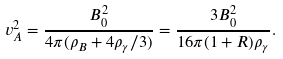<formula> <loc_0><loc_0><loc_500><loc_500>v _ { A } ^ { 2 } = \frac { B _ { 0 } ^ { 2 } } { 4 \pi ( \rho _ { B } + 4 \rho _ { \gamma } / 3 ) } = \frac { 3 B _ { 0 } ^ { 2 } } { 1 6 \pi ( 1 + R ) \rho _ { \gamma } } .</formula> 